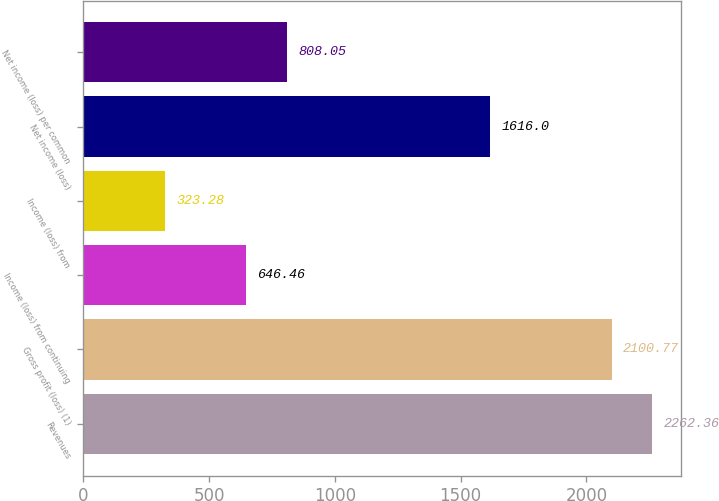Convert chart to OTSL. <chart><loc_0><loc_0><loc_500><loc_500><bar_chart><fcel>Revenues<fcel>Gross profit (loss) (1)<fcel>Income (loss) from continuing<fcel>Income (loss) from<fcel>Net income (loss)<fcel>Net income (loss) per common<nl><fcel>2262.36<fcel>2100.77<fcel>646.46<fcel>323.28<fcel>1616<fcel>808.05<nl></chart> 